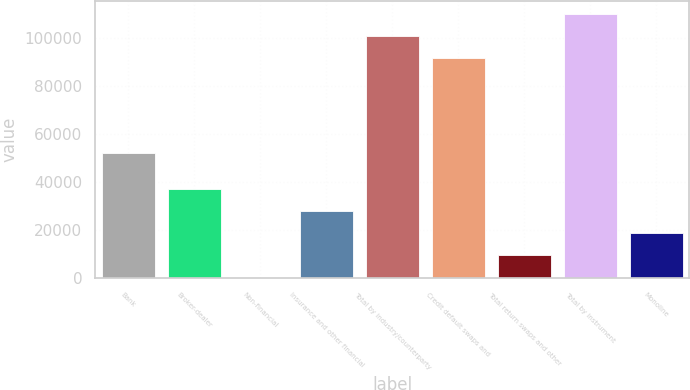Convert chart. <chart><loc_0><loc_0><loc_500><loc_500><bar_chart><fcel>Bank<fcel>Broker-dealer<fcel>Non-financial<fcel>Insurance and other financial<fcel>Total by industry/counterparty<fcel>Credit default swaps and<fcel>Total return swaps and other<fcel>Total by instrument<fcel>Monoline<nl><fcel>52383<fcel>37320.2<fcel>339<fcel>28074.9<fcel>100870<fcel>91625<fcel>9584.3<fcel>110116<fcel>18829.6<nl></chart> 